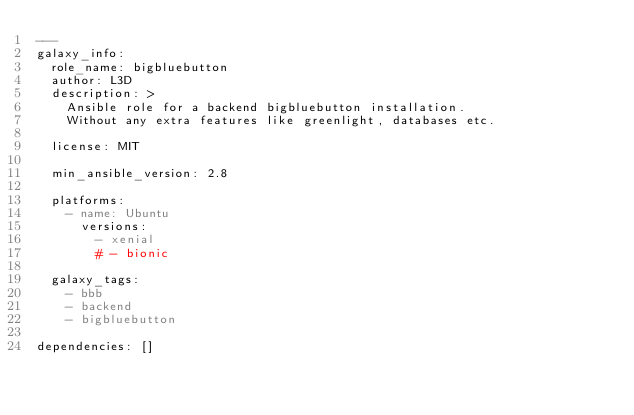<code> <loc_0><loc_0><loc_500><loc_500><_YAML_>---
galaxy_info:
  role_name: bigbluebutton
  author: L3D
  description: >
    Ansible role for a backend bigbluebutton installation.
    Without any extra features like greenlight, databases etc.

  license: MIT

  min_ansible_version: 2.8

  platforms:
    - name: Ubuntu
      versions:
        - xenial
        # - bionic

  galaxy_tags:
    - bbb
    - backend
    - bigbluebutton

dependencies: []
</code> 